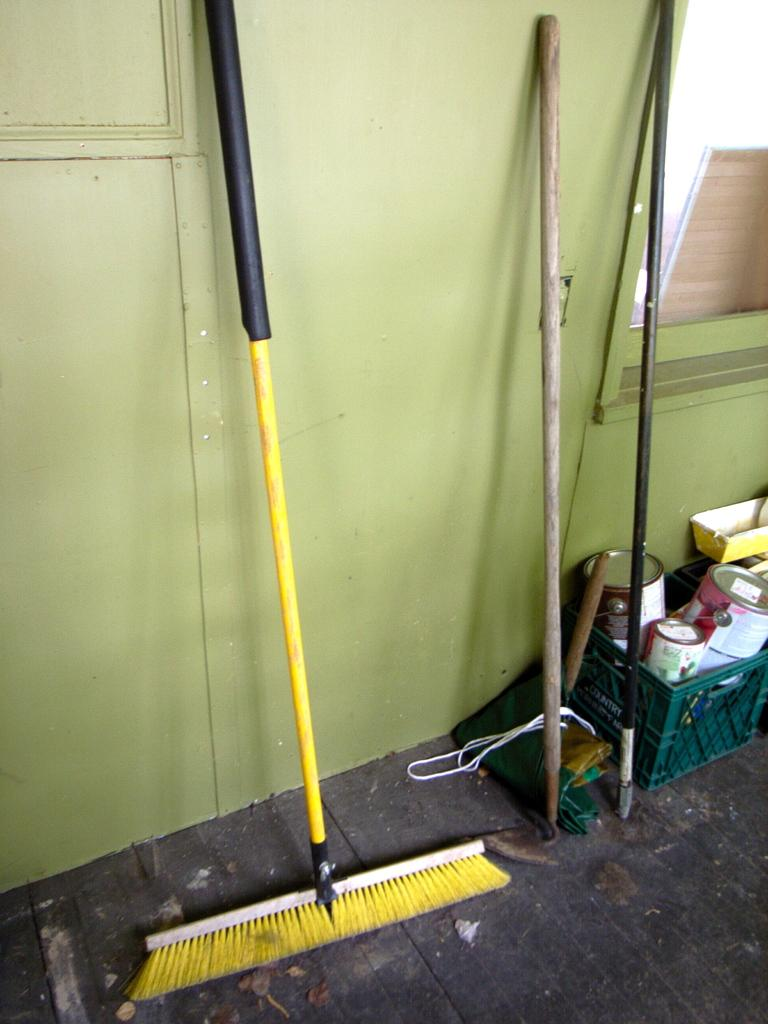What is the main subject of the image? The main subject of the image is a sweeper. What colors are used for the sweeper? The sweeper is yellow and black in color. What can be seen on the floor in the image? There are objects on the floor in the image. What color is the wall in the image? The wall in the image is green. Where is the doll placed in relation to the sweeper in the image? There is no doll present in the image. What type of picture is hanging on the green wall in the image? There is no picture hanging on the green wall in the image. 